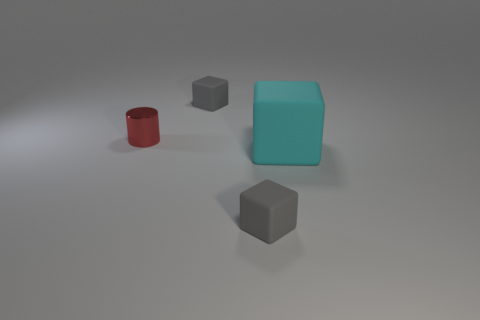There is a small gray object that is in front of the matte thing behind the small metal cylinder; what shape is it?
Ensure brevity in your answer.  Cube. How many red shiny cylinders have the same size as the shiny thing?
Make the answer very short. 0. Are any purple objects visible?
Your answer should be compact. No. Is there any other thing of the same color as the metal thing?
Offer a terse response. No. There is a matte block that is in front of the thing that is to the right of the small cube in front of the cylinder; what color is it?
Your response must be concise. Gray. Is the number of tiny metal objects that are behind the tiny red cylinder the same as the number of blue objects?
Provide a short and direct response. Yes. Is there any other thing that is made of the same material as the big cyan cube?
Offer a very short reply. Yes. There is a cylinder; is its color the same as the thing that is in front of the cyan thing?
Offer a terse response. No. There is a small thing to the right of the small gray block that is behind the metallic cylinder; are there any rubber objects to the left of it?
Offer a very short reply. Yes. Is the number of small gray cubes to the left of the metal cylinder less than the number of tiny red metal objects?
Your answer should be compact. Yes. 